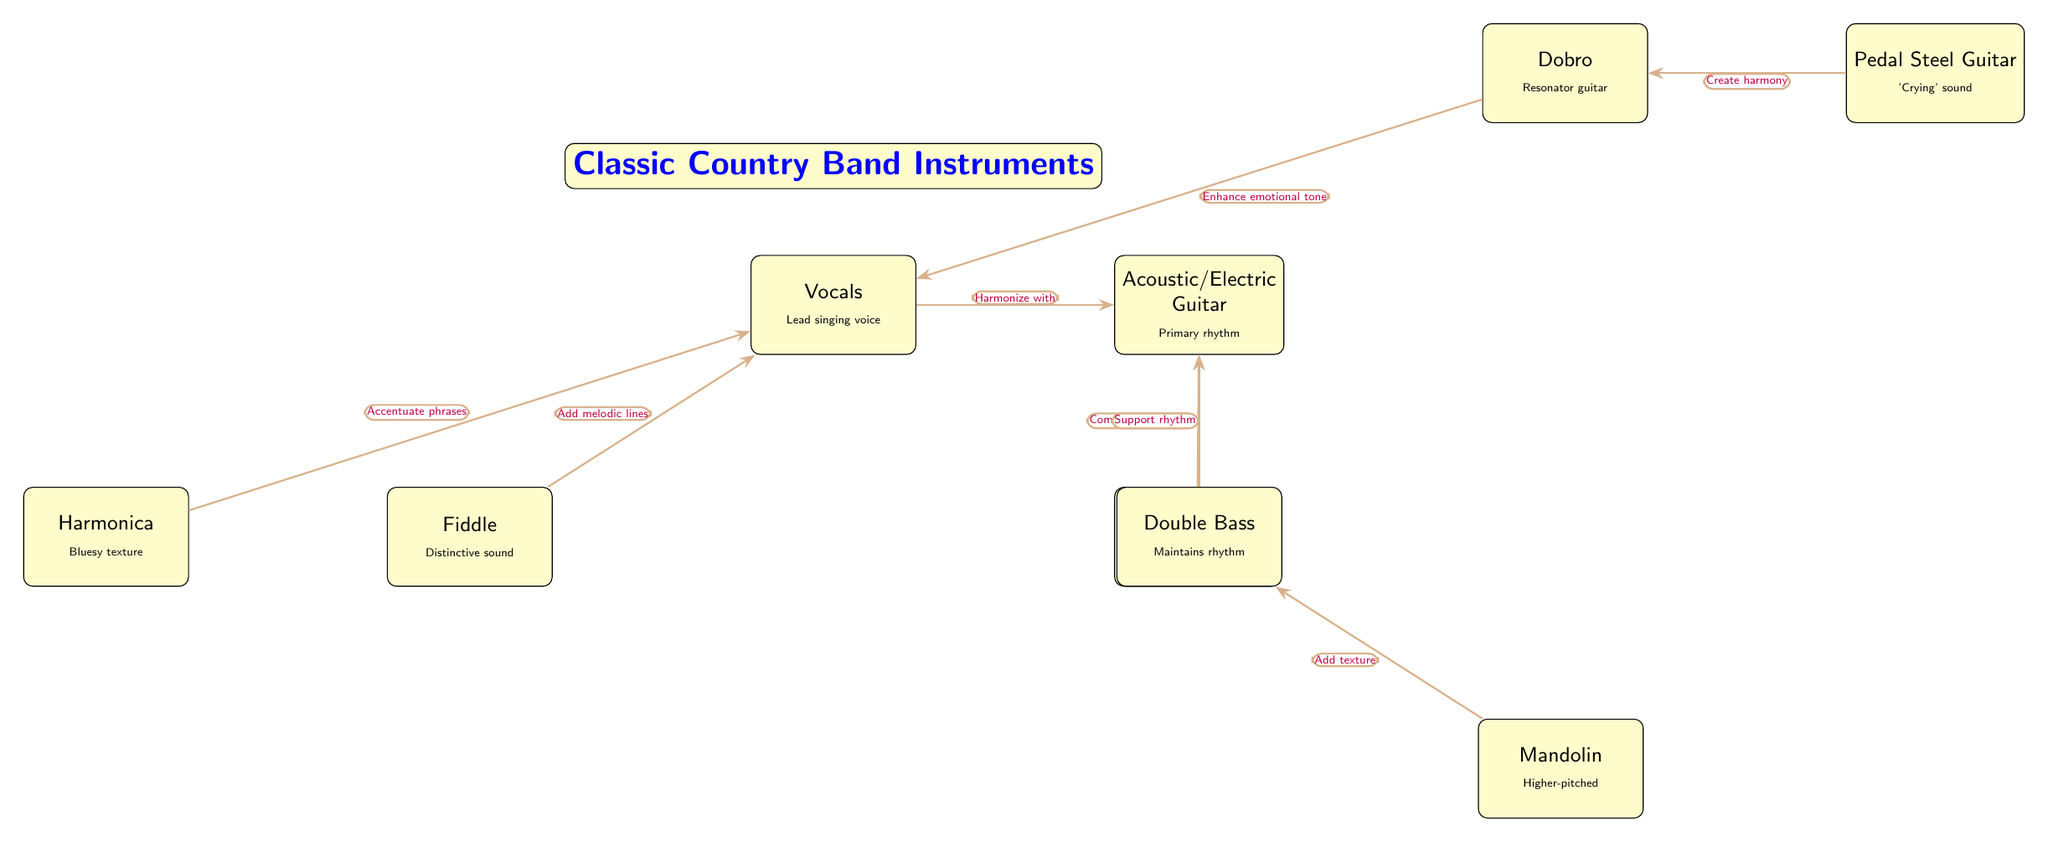What are the primary rhythm instruments in the classic country band? The diagram indicates that the primary rhythm instrument is the Acoustic/Electric Guitar, as it is specifically labeled with that role.
Answer: Acoustic/Electric Guitar Which instrument complements the rhythm of the guitar? According to the diagram, the Banjo is connected to the guitar with the label "Complement rhythm," indicating its role in working alongside the guitar in that capacity.
Answer: Banjo How many instruments are represented in the diagram? Counting each distinct instrument node present in the diagram shows there are eight instruments listed altogether.
Answer: 8 What role does the Fiddle play in relation to the Vocals? The diagram states that the Fiddle "Add melodic lines" to the Vocals, establishing a direct contribution from the Fiddle to the vocal performance.
Answer: Add melodic lines Which instrument enhances the emotional tone of the Vocals? Referring to the connections in the diagram shows that the Dobro is connected to the Vocals with the label "Enhance emotional tone," indicating its specific role in supporting the Vocals.
Answer: Dobro How do the Harmonica and Vocals interact in the band? The edges in the diagram confirm that the Harmonica is linked to the Vocals with the note "Accentuate phrases," showing its interaction specifically enhances what is performed vocally.
Answer: Accentuate phrases Which instrument is described as having a 'Crying' sound? Based on the node descriptions in the diagram, the Pedal Steel Guitar is specifically noted for its characteristic 'Crying' sound.
Answer: Pedal Steel Guitar What is the relationship between the Steel Guitar and Dobro? The diagram illustrates that the Steel Guitar creates harmony with the Dobro, indicating a collaborative connection between these two instruments in producing musical harmony.
Answer: Create harmony 